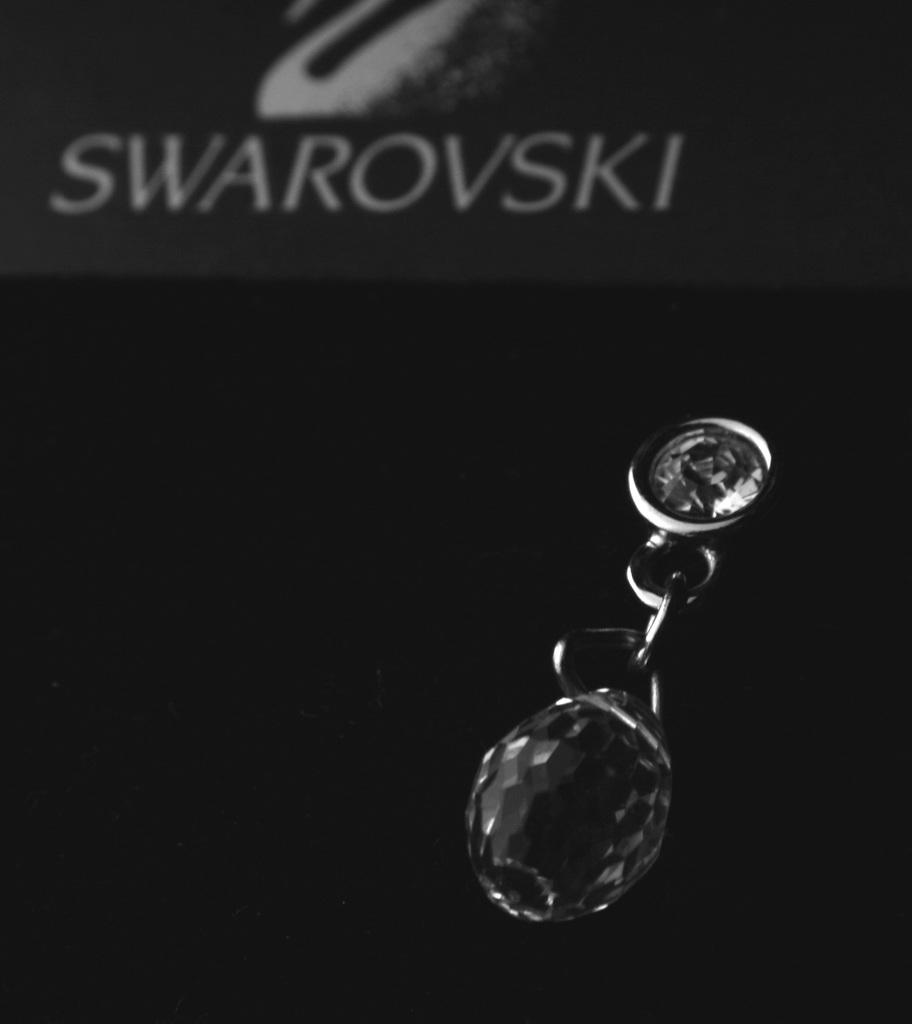What is the main object in the image? There is a diamond-like object on a chain in the image. What can be observed about the background of the image? The background of the image is dark. Is there any text present in the image? Yes, there is text written at the top of the image. Can you tell me how many wrens are perched on the diamond-like object in the image? There are no wrens present in the image; it features a diamond-like object on a chain. What type of dinner is being served in the image? There is no dinner or any food visible in the image. 